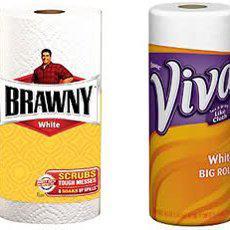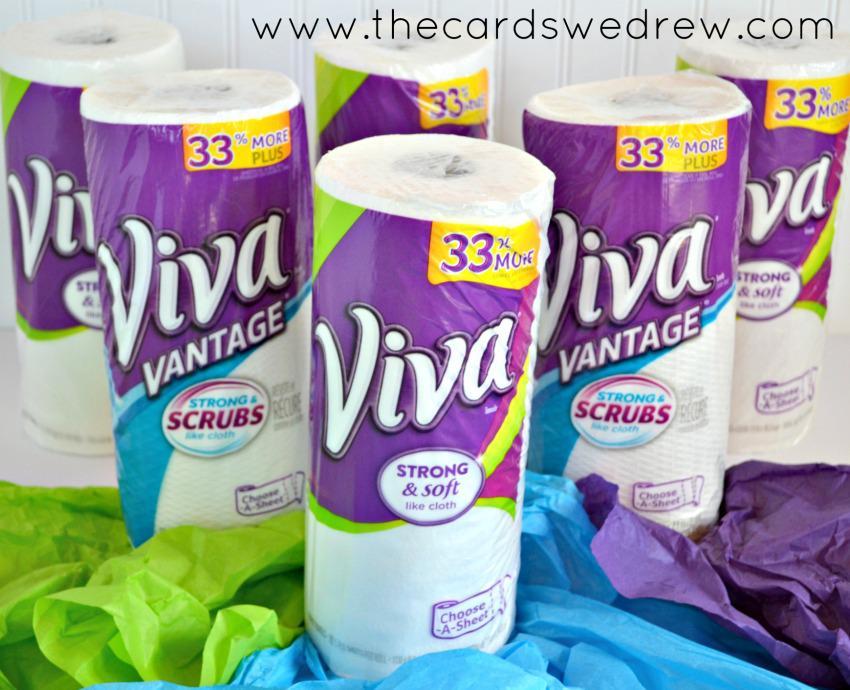The first image is the image on the left, the second image is the image on the right. Assess this claim about the two images: "One image shows a poster with consumer items in front of it, and the other image shows individiually wrapped paper towel rolls.". Correct or not? Answer yes or no. No. The first image is the image on the left, the second image is the image on the right. Given the left and right images, does the statement "One image shows an upright poster for a school science fair project, while a second image shows at least three wrapped rolls of paper towels, all different brands." hold true? Answer yes or no. No. 